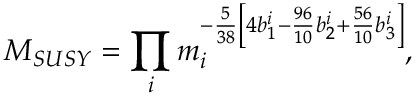Convert formula to latex. <formula><loc_0><loc_0><loc_500><loc_500>M _ { S U S Y } = \prod _ { i } m _ { i } ^ { - \frac { 5 } { 3 8 } \left [ 4 b _ { 1 } ^ { i } - \frac { 9 6 } { 1 0 } b _ { 2 } ^ { i } + \frac { 5 6 } { 1 0 } b _ { 3 } ^ { i } \right ] } ,</formula> 